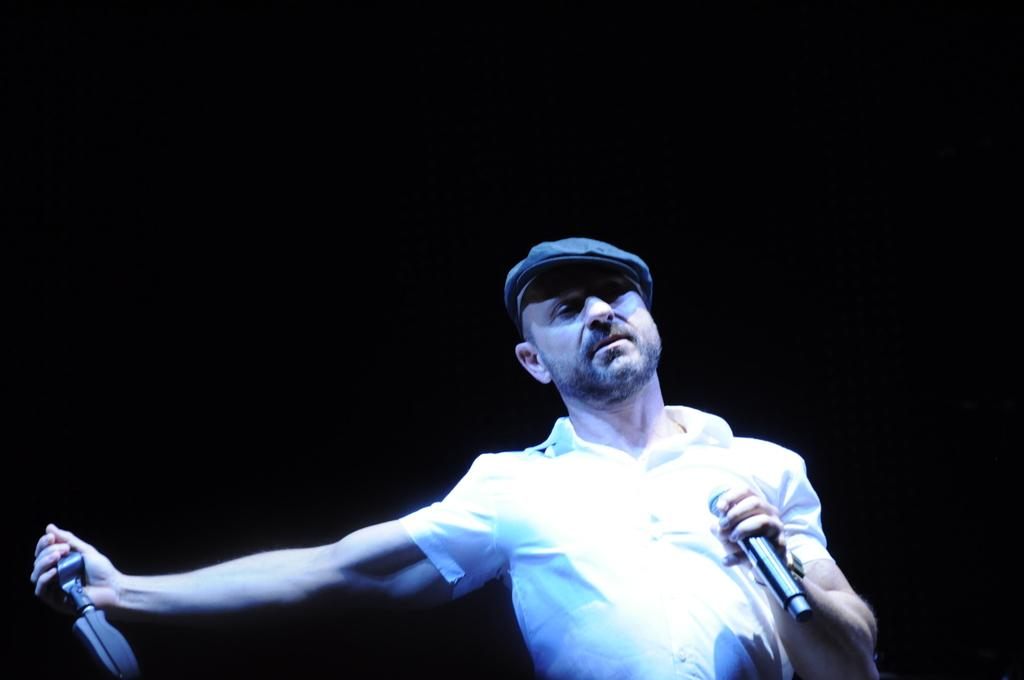What can be seen in the image? There is a person in the image. What is the person wearing? The person is wearing a white shirt and a hat. What is the person holding in their left hand? The person is holding a microphone in their left hand. What is the person holding in their right hand? The person is holding something in their right hand, but the specific object is not mentioned in the facts. What is the color of the background in the image? The background of the image is black. Can you hear the sound of thunder in the image? There is no sound or audio in the image, so it is not possible to hear thunder or any other sounds. 